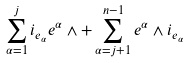Convert formula to latex. <formula><loc_0><loc_0><loc_500><loc_500>\sum _ { \alpha = 1 } ^ { j } i _ { e _ { \alpha } } { e ^ { \alpha } } \wedge + \sum _ { \alpha = j + 1 } ^ { n - 1 } { e ^ { \alpha } } \wedge i _ { e _ { \alpha } }</formula> 